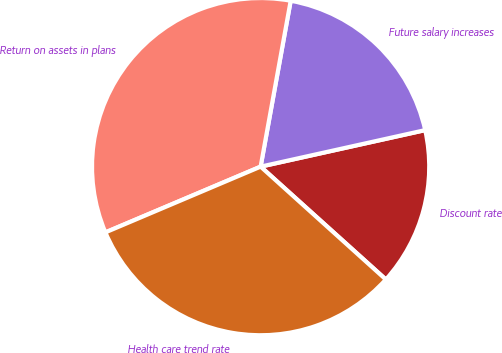Convert chart. <chart><loc_0><loc_0><loc_500><loc_500><pie_chart><fcel>Discount rate<fcel>Future salary increases<fcel>Return on assets in plans<fcel>Health care trend rate<nl><fcel>15.15%<fcel>18.67%<fcel>34.23%<fcel>31.95%<nl></chart> 